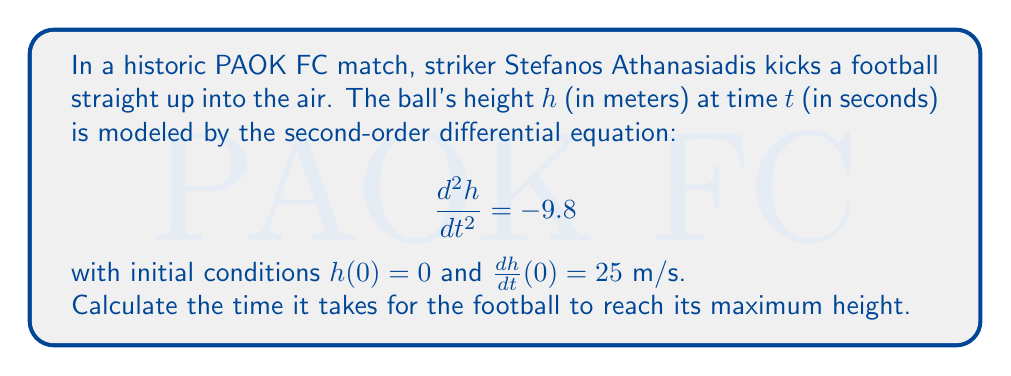Teach me how to tackle this problem. To solve this problem, we'll follow these steps:

1) First, we need to solve the differential equation. The general solution for this second-order linear equation is:

   $$h(t) = -4.9t^2 + At + B$$

   where $A$ and $B$ are constants we'll determine from the initial conditions.

2) Using the initial condition $h(0) = 0$:

   $$0 = -4.9(0)^2 + A(0) + B$$
   $$B = 0$$

3) For the second initial condition, we need to find $\frac{dh}{dt}$:

   $$\frac{dh}{dt} = -9.8t + A$$

   Using $\frac{dh}{dt}(0) = 25$:

   $$25 = -9.8(0) + A$$
   $$A = 25$$

4) So our specific solution is:

   $$h(t) = -4.9t^2 + 25t$$

5) To find the time of maximum height, we need to find when $\frac{dh}{dt} = 0$:

   $$\frac{dh}{dt} = -9.8t + 25 = 0$$
   $$-9.8t = -25$$
   $$t = \frac{25}{9.8} \approx 2.55$$

Therefore, the ball reaches its maximum height after approximately 2.55 seconds.
Answer: $t \approx 2.55$ seconds 